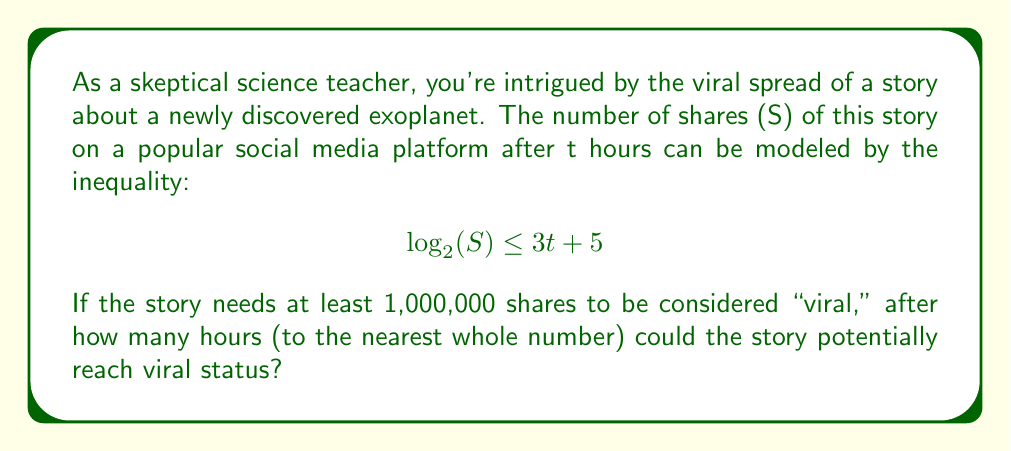Give your solution to this math problem. Let's approach this step-by-step:

1) We're told that for the story to be considered viral, it needs at least 1,000,000 shares. So we need to solve:

   $$\log_2(1,000,000) \leq 3t + 5$$

2) First, let's simplify the left side:
   
   $$\log_2(1,000,000) = \log_2(10^6) = 6 \log_2(10) \approx 19.93$$

3) Now our inequality becomes:

   $$19.93 \leq 3t + 5$$

4) Subtract 5 from both sides:

   $$14.93 \leq 3t$$

5) Divide both sides by 3:

   $$4.98 \leq t$$

6) Since we're asked for the nearest whole number of hours, and t needs to be at least 4.98, we round up to 5.

Therefore, after 5 hours, the story could potentially reach viral status.
Answer: 5 hours 